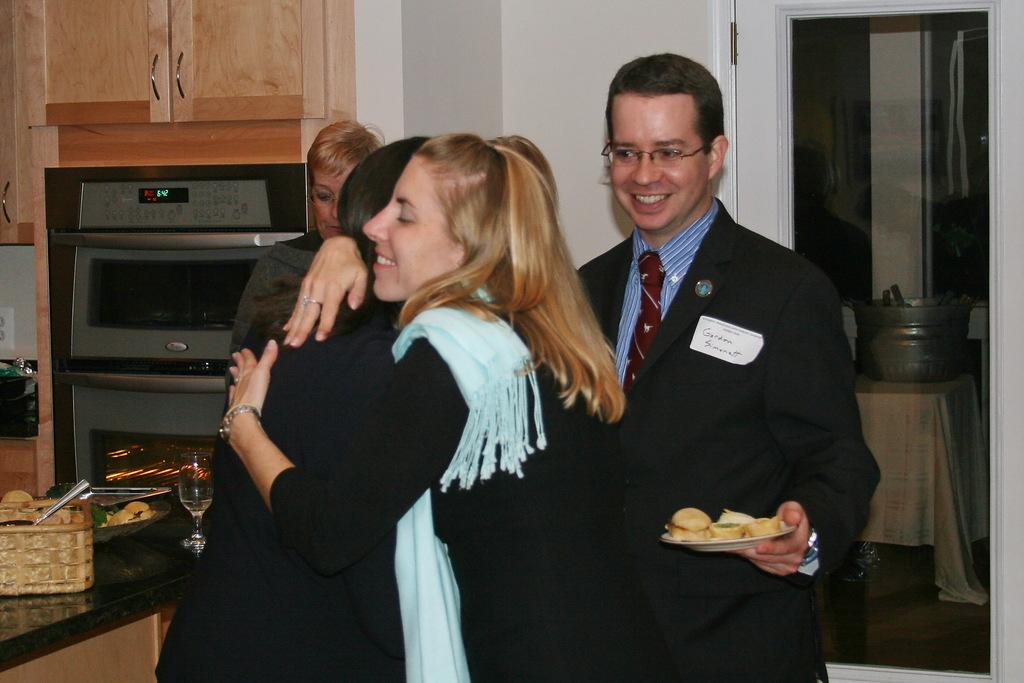<image>
Render a clear and concise summary of the photo. A man with a name tag reading Gordon Smith holding a plate of food 